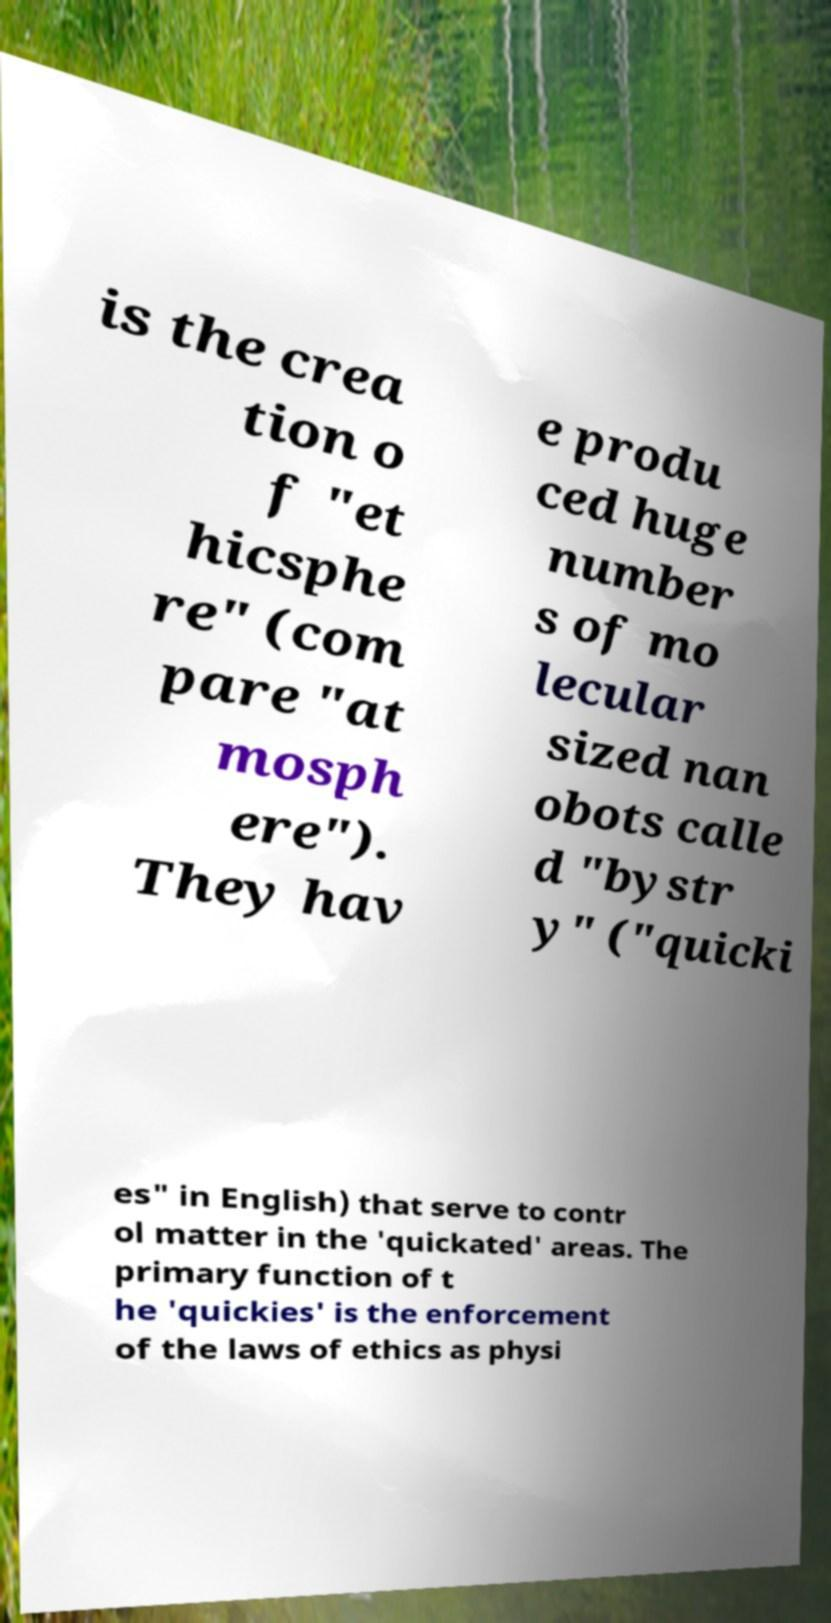For documentation purposes, I need the text within this image transcribed. Could you provide that? is the crea tion o f "et hicsphe re" (com pare "at mosph ere"). They hav e produ ced huge number s of mo lecular sized nan obots calle d "bystr y" ("quicki es" in English) that serve to contr ol matter in the 'quickated' areas. The primary function of t he 'quickies' is the enforcement of the laws of ethics as physi 